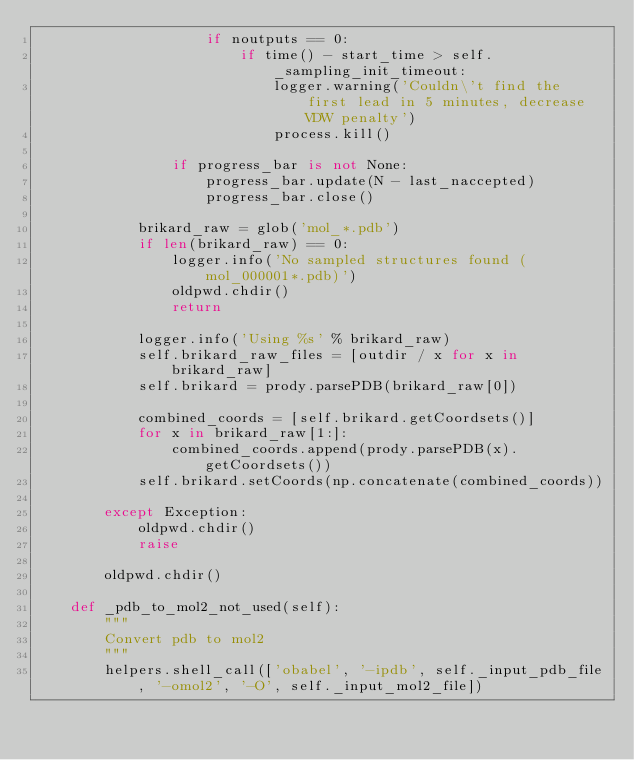Convert code to text. <code><loc_0><loc_0><loc_500><loc_500><_Python_>                    if noutputs == 0:
                        if time() - start_time > self._sampling_init_timeout:
                            logger.warning('Couldn\'t find the first lead in 5 minutes, decrease VDW penalty')
                            process.kill()

                if progress_bar is not None:
                    progress_bar.update(N - last_naccepted)
                    progress_bar.close()

            brikard_raw = glob('mol_*.pdb')
            if len(brikard_raw) == 0:
                logger.info('No sampled structures found (mol_000001*.pdb)')
                oldpwd.chdir()
                return

            logger.info('Using %s' % brikard_raw)
            self.brikard_raw_files = [outdir / x for x in brikard_raw]
            self.brikard = prody.parsePDB(brikard_raw[0])

            combined_coords = [self.brikard.getCoordsets()]
            for x in brikard_raw[1:]:
                combined_coords.append(prody.parsePDB(x).getCoordsets())
            self.brikard.setCoords(np.concatenate(combined_coords))

        except Exception:
            oldpwd.chdir()
            raise

        oldpwd.chdir()

    def _pdb_to_mol2_not_used(self):
        """
        Convert pdb to mol2
        """
        helpers.shell_call(['obabel', '-ipdb', self._input_pdb_file, '-omol2', '-O', self._input_mol2_file])
</code> 